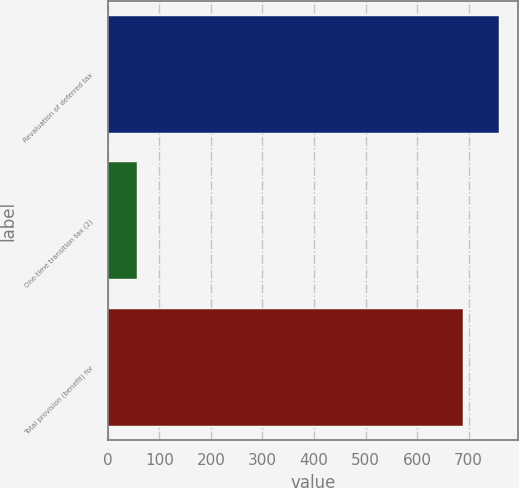Convert chart to OTSL. <chart><loc_0><loc_0><loc_500><loc_500><bar_chart><fcel>Revaluation of deferred tax<fcel>One-time transition tax (2)<fcel>Total provision (benefit) for<nl><fcel>757.9<fcel>57<fcel>689<nl></chart> 